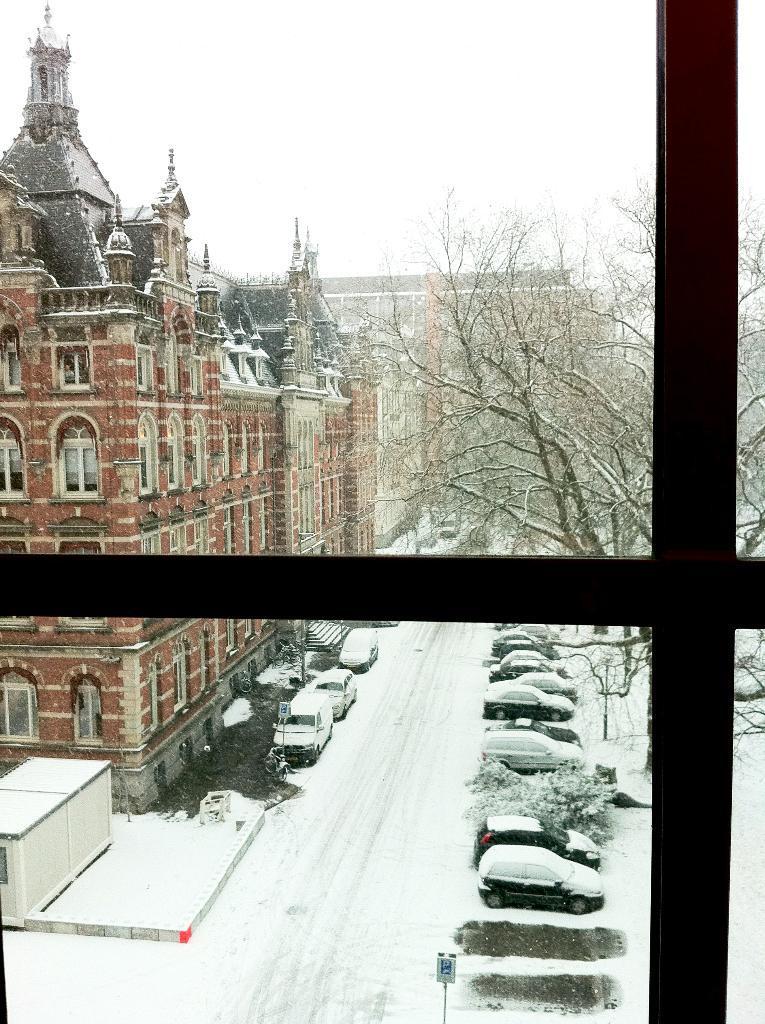Can you describe this image briefly? In the image we can see in front there is a window and outside the window there is a building. There are cars parked on the road and the road is covered with snow. Behind there are lot of trees. 